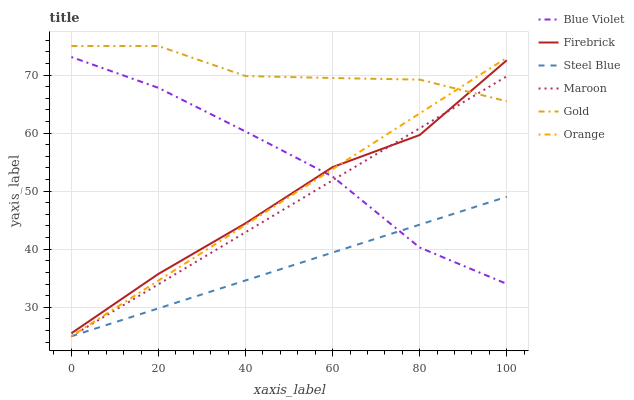Does Steel Blue have the minimum area under the curve?
Answer yes or no. Yes. Does Gold have the maximum area under the curve?
Answer yes or no. Yes. Does Firebrick have the minimum area under the curve?
Answer yes or no. No. Does Firebrick have the maximum area under the curve?
Answer yes or no. No. Is Steel Blue the smoothest?
Answer yes or no. Yes. Is Firebrick the roughest?
Answer yes or no. Yes. Is Firebrick the smoothest?
Answer yes or no. No. Is Steel Blue the roughest?
Answer yes or no. No. Does Steel Blue have the lowest value?
Answer yes or no. Yes. Does Firebrick have the lowest value?
Answer yes or no. No. Does Gold have the highest value?
Answer yes or no. Yes. Does Firebrick have the highest value?
Answer yes or no. No. Is Blue Violet less than Gold?
Answer yes or no. Yes. Is Firebrick greater than Steel Blue?
Answer yes or no. Yes. Does Steel Blue intersect Orange?
Answer yes or no. Yes. Is Steel Blue less than Orange?
Answer yes or no. No. Is Steel Blue greater than Orange?
Answer yes or no. No. Does Blue Violet intersect Gold?
Answer yes or no. No. 